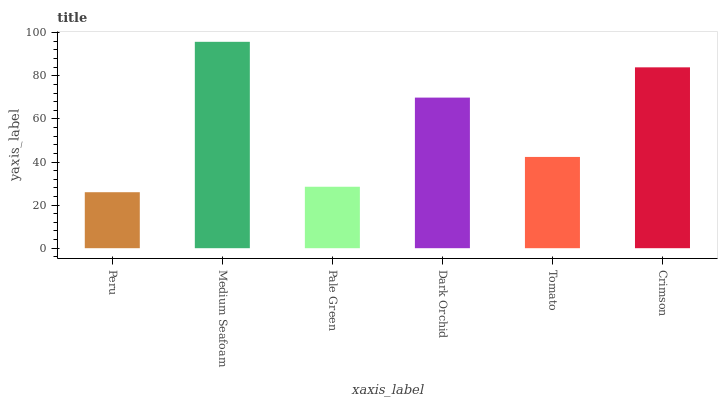Is Peru the minimum?
Answer yes or no. Yes. Is Medium Seafoam the maximum?
Answer yes or no. Yes. Is Pale Green the minimum?
Answer yes or no. No. Is Pale Green the maximum?
Answer yes or no. No. Is Medium Seafoam greater than Pale Green?
Answer yes or no. Yes. Is Pale Green less than Medium Seafoam?
Answer yes or no. Yes. Is Pale Green greater than Medium Seafoam?
Answer yes or no. No. Is Medium Seafoam less than Pale Green?
Answer yes or no. No. Is Dark Orchid the high median?
Answer yes or no. Yes. Is Tomato the low median?
Answer yes or no. Yes. Is Pale Green the high median?
Answer yes or no. No. Is Pale Green the low median?
Answer yes or no. No. 